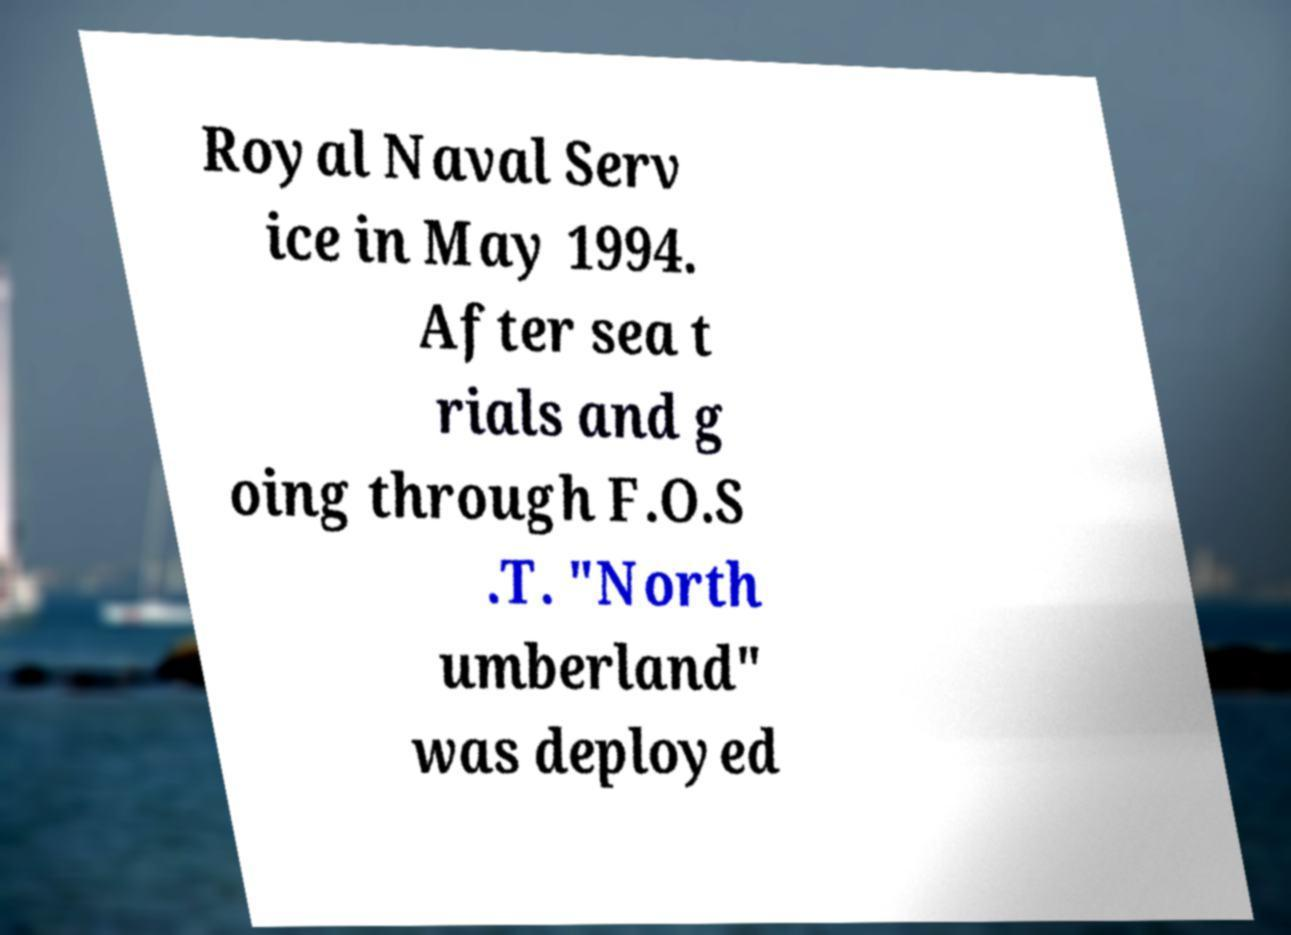Could you assist in decoding the text presented in this image and type it out clearly? Royal Naval Serv ice in May 1994. After sea t rials and g oing through F.O.S .T. "North umberland" was deployed 